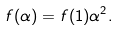Convert formula to latex. <formula><loc_0><loc_0><loc_500><loc_500>f ( \alpha ) = f ( 1 ) \alpha ^ { 2 } .</formula> 